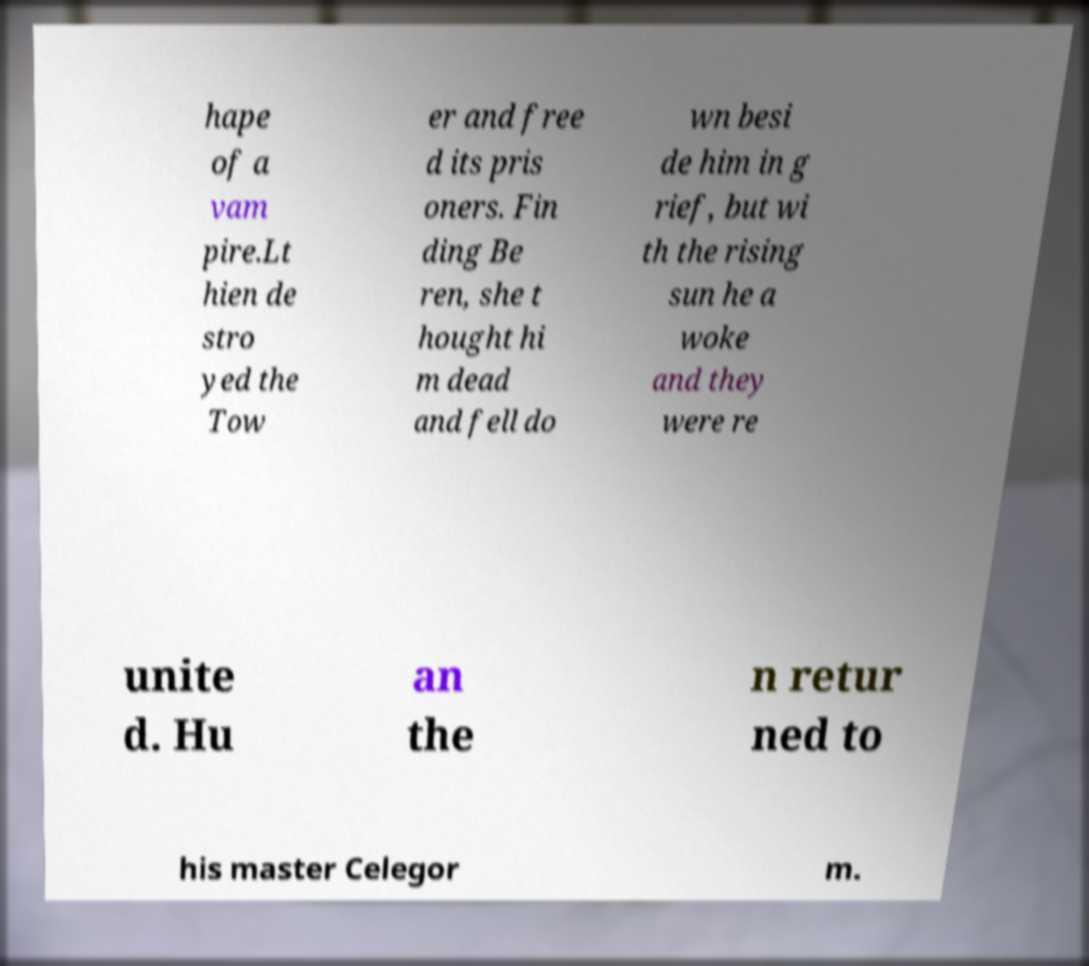Could you assist in decoding the text presented in this image and type it out clearly? hape of a vam pire.Lt hien de stro yed the Tow er and free d its pris oners. Fin ding Be ren, she t hought hi m dead and fell do wn besi de him in g rief, but wi th the rising sun he a woke and they were re unite d. Hu an the n retur ned to his master Celegor m. 